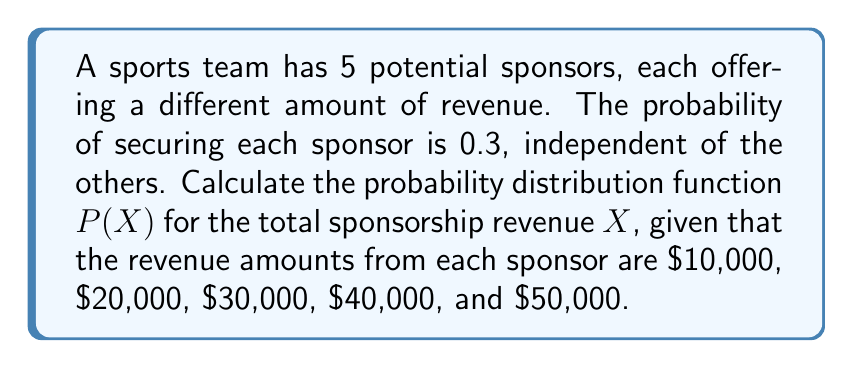Help me with this question. 1. This problem can be modeled as a sum of independent Bernoulli random variables, each with probability $p = 0.3$.

2. Let $X_i$ be the random variable representing the revenue from sponsor $i$, where $i = 1, 2, 3, 4, 5$.

3. The probability generating function (PGF) for each $X_i$ is:
   $$G_{X_i}(z) = 0.7 + 0.3z^{r_i}$$
   where $r_i$ is the revenue amount in units of $10,000.

4. The PGF for the total revenue $X$ is the product of individual PGFs:
   $$G_X(z) = \prod_{i=1}^5 (0.7 + 0.3z^i)$$

5. Expanding this product:
   $$G_X(z) = 0.16807 + 0.21609z + 0.22059z^2 + 0.18522z^3 + 0.11988z^4 + 0.06123z^5 + 0.02430z^6 + 0.00729z^7 + 0.00162z^8 + 0.00024z^9 + 0.00002z^{10}$$

6. The coefficients of this polynomial give the probability distribution function $P(X)$:
   $$P(X = 0) = 0.16807$$
   $$P(X = 10000) = 0.21609$$
   $$P(X = 20000) = 0.22059$$
   $$P(X = 30000) = 0.18522$$
   $$P(X = 40000) = 0.11988$$
   $$P(X = 50000) = 0.06123$$
   $$P(X = 60000) = 0.02430$$
   $$P(X = 70000) = 0.00729$$
   $$P(X = 80000) = 0.00162$$
   $$P(X = 90000) = 0.00024$$
   $$P(X = 100000) = 0.00002$$
Answer: $P(X) = \{0.16807, 0.21609, 0.22059, 0.18522, 0.11988, 0.06123, 0.02430, 0.00729, 0.00162, 0.00024, 0.00002\}$ for $X = \{0, 10000, 20000, ..., 100000\}$ 